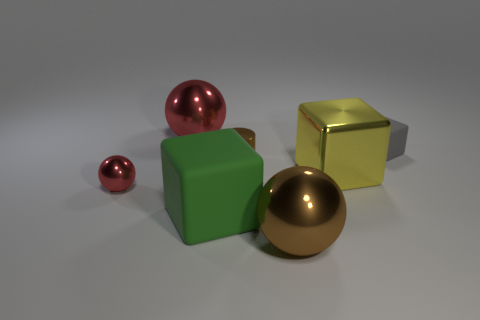Add 2 big brown metal spheres. How many objects exist? 9 Subtract all gray blocks. How many blocks are left? 2 Subtract all tiny gray matte blocks. How many blocks are left? 2 Subtract 0 cyan cubes. How many objects are left? 7 Subtract all cylinders. How many objects are left? 6 Subtract 1 blocks. How many blocks are left? 2 Subtract all blue balls. Subtract all blue cubes. How many balls are left? 3 Subtract all green cylinders. How many gray balls are left? 0 Subtract all small gray matte objects. Subtract all red balls. How many objects are left? 4 Add 7 rubber objects. How many rubber objects are left? 9 